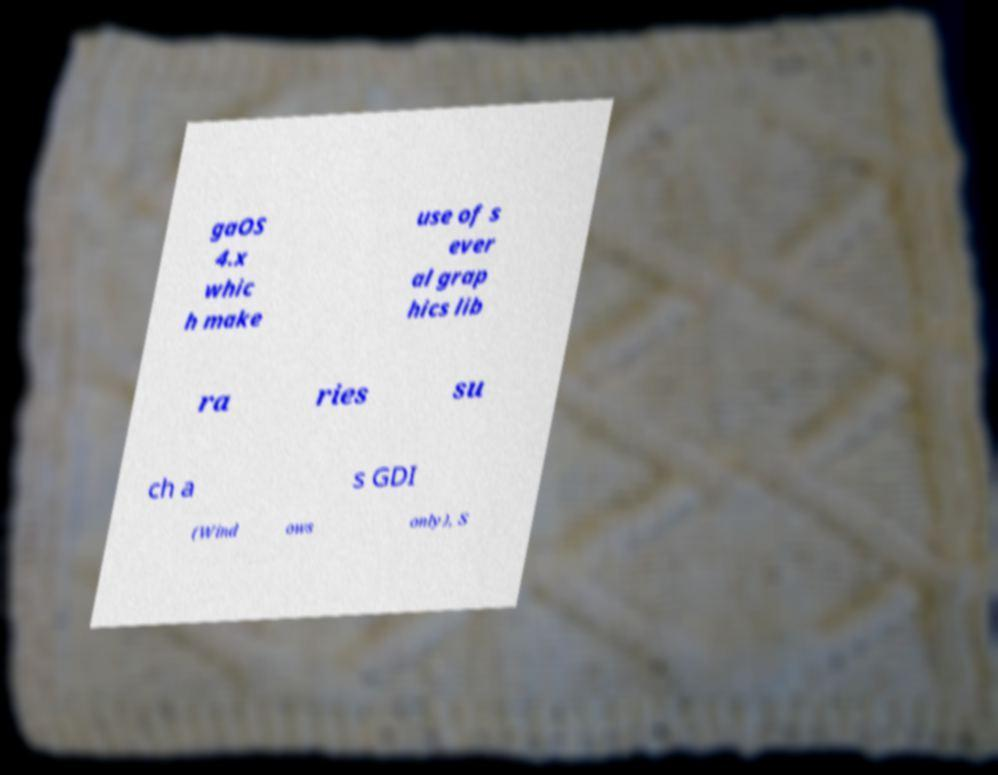Can you accurately transcribe the text from the provided image for me? gaOS 4.x whic h make use of s ever al grap hics lib ra ries su ch a s GDI (Wind ows only), S 